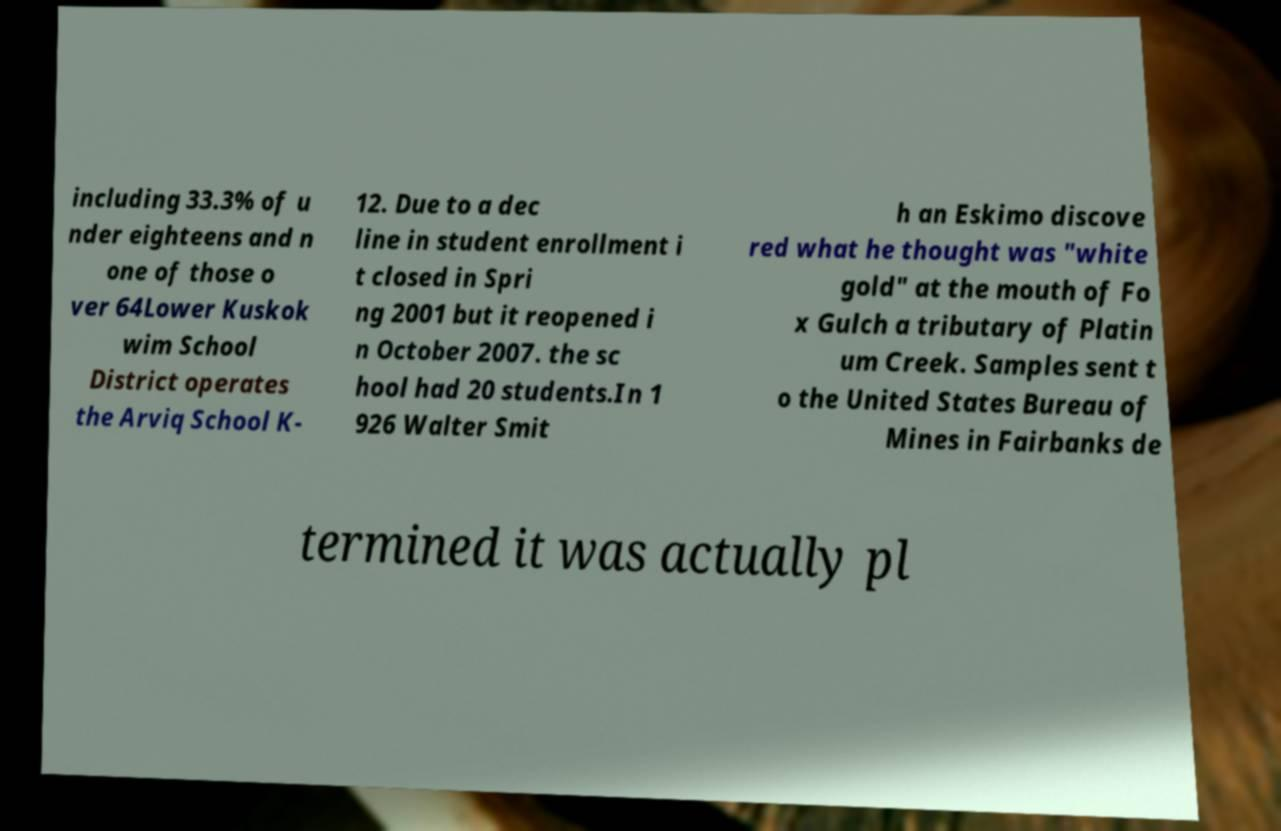Can you accurately transcribe the text from the provided image for me? including 33.3% of u nder eighteens and n one of those o ver 64Lower Kuskok wim School District operates the Arviq School K- 12. Due to a dec line in student enrollment i t closed in Spri ng 2001 but it reopened i n October 2007. the sc hool had 20 students.In 1 926 Walter Smit h an Eskimo discove red what he thought was "white gold" at the mouth of Fo x Gulch a tributary of Platin um Creek. Samples sent t o the United States Bureau of Mines in Fairbanks de termined it was actually pl 